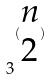<formula> <loc_0><loc_0><loc_500><loc_500>3 ^ { ( \begin{matrix} n \\ 2 \end{matrix} ) }</formula> 